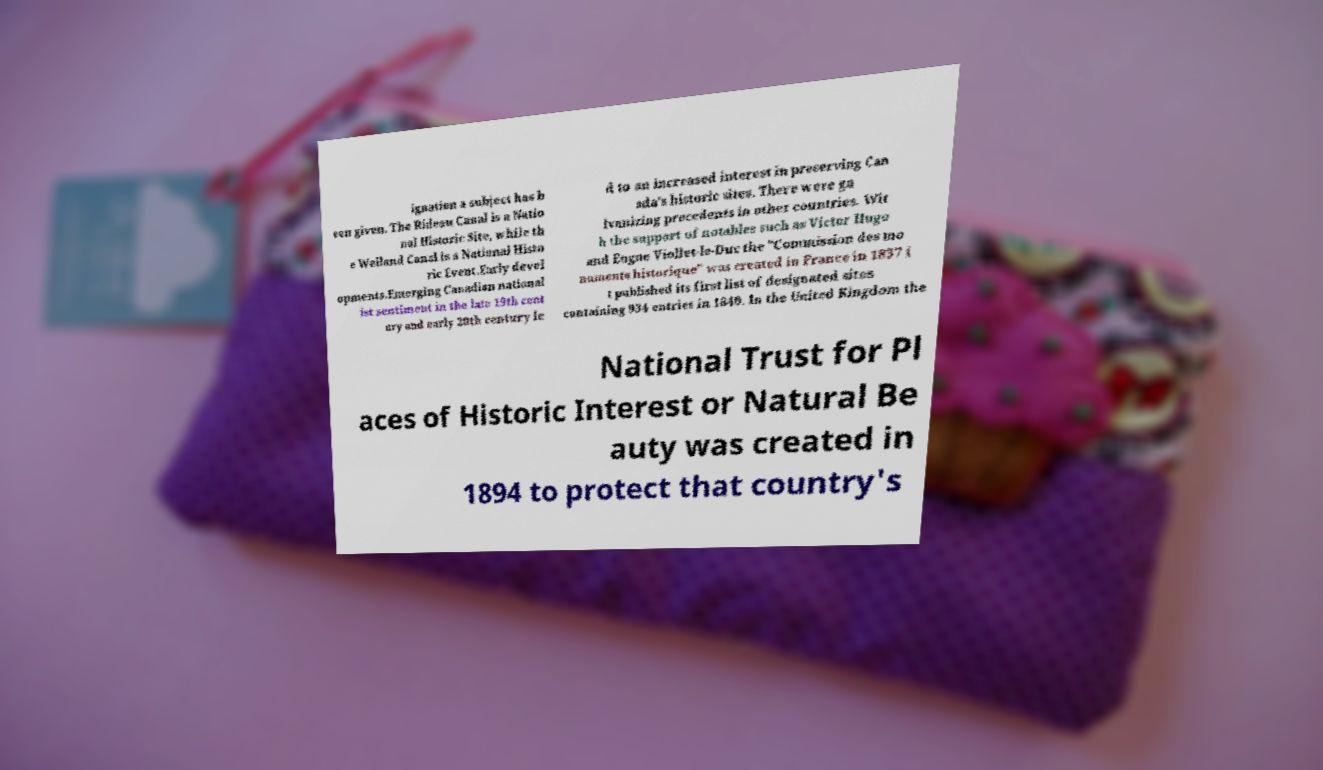I need the written content from this picture converted into text. Can you do that? ignation a subject has b een given. The Rideau Canal is a Natio nal Historic Site, while th e Welland Canal is a National Histo ric Event.Early devel opments.Emerging Canadian national ist sentiment in the late 19th cent ury and early 20th century le d to an increased interest in preserving Can ada's historic sites. There were ga lvanizing precedents in other countries. Wit h the support of notables such as Victor Hugo and Eugne Viollet-le-Duc the "Commission des mo numents historique" was created in France in 1837 i t published its first list of designated sites containing 934 entries in 1840. In the United Kingdom the National Trust for Pl aces of Historic Interest or Natural Be auty was created in 1894 to protect that country's 